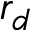<formula> <loc_0><loc_0><loc_500><loc_500>r _ { d }</formula> 